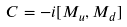Convert formula to latex. <formula><loc_0><loc_0><loc_500><loc_500>C = - i [ M _ { u } , M _ { d } ]</formula> 